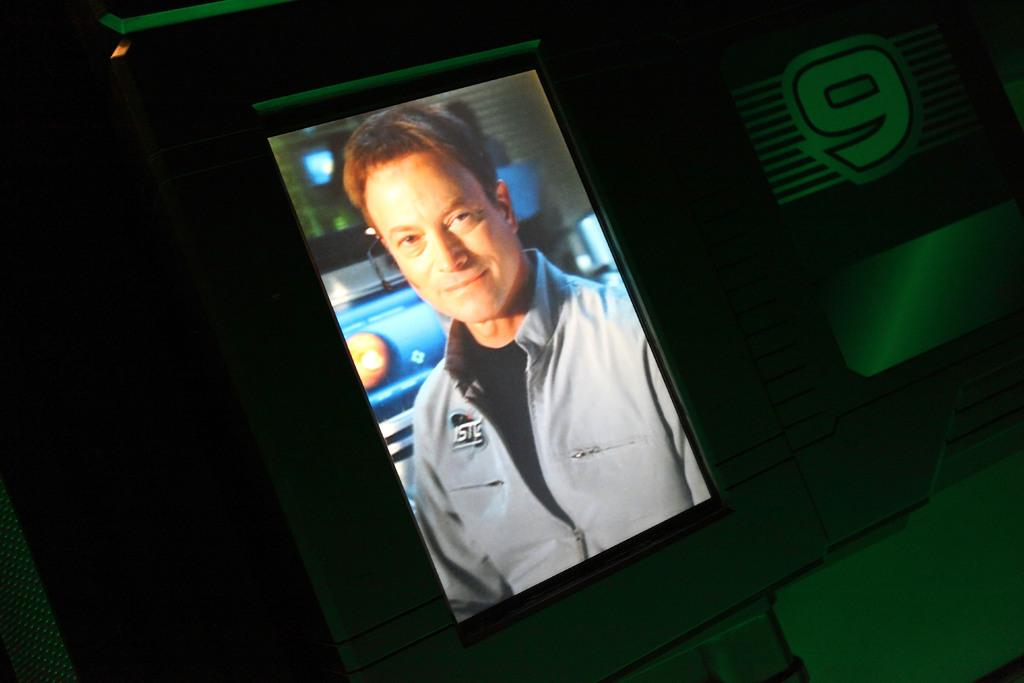What is the main subject of the image? There is a person visible on a display screen in the image. How does the person on the display screen plan to join the glue-making competition with their aunt? There is no information about a glue-making competition or an aunt in the image, so it is not possible to answer that question. 